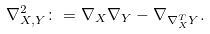<formula> <loc_0><loc_0><loc_500><loc_500>\nabla ^ { 2 } _ { X , Y } \colon = \nabla _ { X } \nabla _ { Y } - \nabla _ { \nabla ^ { T } _ { X } Y } .</formula> 